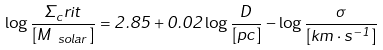<formula> <loc_0><loc_0><loc_500><loc_500>\log \frac { \Sigma _ { c } r i t } { [ M _ { \ s o l a r } ] } = 2 . 8 5 + 0 . 0 2 \log \frac { D } { [ p c ] } - \log \frac { \sigma } { [ k m \cdot s ^ { - 1 } ] }</formula> 